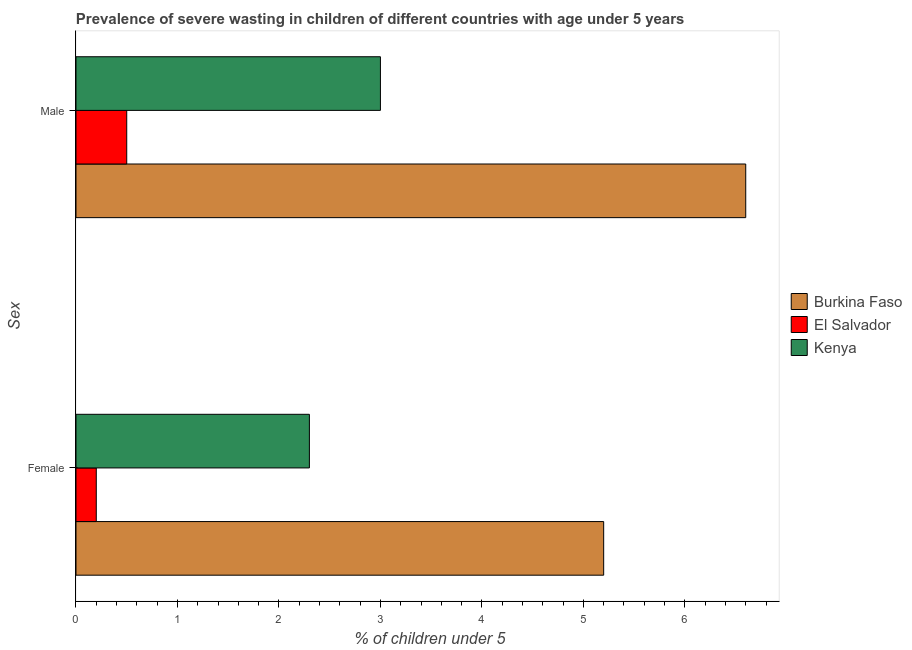How many groups of bars are there?
Provide a succinct answer. 2. Are the number of bars per tick equal to the number of legend labels?
Ensure brevity in your answer.  Yes. How many bars are there on the 1st tick from the bottom?
Provide a succinct answer. 3. What is the percentage of undernourished female children in Kenya?
Provide a succinct answer. 2.3. Across all countries, what is the maximum percentage of undernourished male children?
Ensure brevity in your answer.  6.6. Across all countries, what is the minimum percentage of undernourished female children?
Make the answer very short. 0.2. In which country was the percentage of undernourished female children maximum?
Keep it short and to the point. Burkina Faso. In which country was the percentage of undernourished female children minimum?
Your answer should be very brief. El Salvador. What is the total percentage of undernourished male children in the graph?
Your response must be concise. 10.1. What is the difference between the percentage of undernourished male children in Kenya and that in Burkina Faso?
Provide a short and direct response. -3.6. What is the difference between the percentage of undernourished male children in Burkina Faso and the percentage of undernourished female children in El Salvador?
Keep it short and to the point. 6.4. What is the average percentage of undernourished female children per country?
Offer a terse response. 2.57. What is the difference between the percentage of undernourished female children and percentage of undernourished male children in El Salvador?
Make the answer very short. -0.3. In how many countries, is the percentage of undernourished female children greater than 5.6 %?
Offer a terse response. 0. What is the ratio of the percentage of undernourished male children in Kenya to that in Burkina Faso?
Ensure brevity in your answer.  0.45. Is the percentage of undernourished male children in Kenya less than that in El Salvador?
Your answer should be very brief. No. In how many countries, is the percentage of undernourished female children greater than the average percentage of undernourished female children taken over all countries?
Your response must be concise. 1. What does the 1st bar from the top in Male represents?
Your answer should be very brief. Kenya. What does the 3rd bar from the bottom in Male represents?
Provide a short and direct response. Kenya. How many bars are there?
Provide a short and direct response. 6. How many countries are there in the graph?
Make the answer very short. 3. What is the difference between two consecutive major ticks on the X-axis?
Offer a terse response. 1. Are the values on the major ticks of X-axis written in scientific E-notation?
Make the answer very short. No. Does the graph contain any zero values?
Keep it short and to the point. No. Where does the legend appear in the graph?
Ensure brevity in your answer.  Center right. How are the legend labels stacked?
Make the answer very short. Vertical. What is the title of the graph?
Provide a short and direct response. Prevalence of severe wasting in children of different countries with age under 5 years. Does "Middle East & North Africa (all income levels)" appear as one of the legend labels in the graph?
Provide a succinct answer. No. What is the label or title of the X-axis?
Give a very brief answer.  % of children under 5. What is the label or title of the Y-axis?
Provide a short and direct response. Sex. What is the  % of children under 5 in Burkina Faso in Female?
Your response must be concise. 5.2. What is the  % of children under 5 of El Salvador in Female?
Your answer should be compact. 0.2. What is the  % of children under 5 of Kenya in Female?
Offer a terse response. 2.3. What is the  % of children under 5 of Burkina Faso in Male?
Keep it short and to the point. 6.6. What is the  % of children under 5 in El Salvador in Male?
Keep it short and to the point. 0.5. Across all Sex, what is the maximum  % of children under 5 of Burkina Faso?
Provide a short and direct response. 6.6. Across all Sex, what is the maximum  % of children under 5 of El Salvador?
Your answer should be very brief. 0.5. Across all Sex, what is the maximum  % of children under 5 of Kenya?
Keep it short and to the point. 3. Across all Sex, what is the minimum  % of children under 5 in Burkina Faso?
Make the answer very short. 5.2. Across all Sex, what is the minimum  % of children under 5 of El Salvador?
Offer a very short reply. 0.2. Across all Sex, what is the minimum  % of children under 5 in Kenya?
Offer a very short reply. 2.3. What is the total  % of children under 5 in El Salvador in the graph?
Provide a succinct answer. 0.7. What is the total  % of children under 5 in Kenya in the graph?
Give a very brief answer. 5.3. What is the difference between the  % of children under 5 in Burkina Faso in Female and that in Male?
Keep it short and to the point. -1.4. What is the difference between the  % of children under 5 in El Salvador in Female and that in Male?
Your answer should be compact. -0.3. What is the difference between the  % of children under 5 in Kenya in Female and that in Male?
Provide a short and direct response. -0.7. What is the average  % of children under 5 of Burkina Faso per Sex?
Ensure brevity in your answer.  5.9. What is the average  % of children under 5 of El Salvador per Sex?
Your answer should be compact. 0.35. What is the average  % of children under 5 of Kenya per Sex?
Ensure brevity in your answer.  2.65. What is the difference between the  % of children under 5 of Burkina Faso and  % of children under 5 of Kenya in Female?
Give a very brief answer. 2.9. What is the difference between the  % of children under 5 in El Salvador and  % of children under 5 in Kenya in Male?
Your answer should be compact. -2.5. What is the ratio of the  % of children under 5 of Burkina Faso in Female to that in Male?
Your answer should be very brief. 0.79. What is the ratio of the  % of children under 5 in Kenya in Female to that in Male?
Provide a succinct answer. 0.77. What is the difference between the highest and the second highest  % of children under 5 in Kenya?
Keep it short and to the point. 0.7. What is the difference between the highest and the lowest  % of children under 5 of Burkina Faso?
Your answer should be compact. 1.4. What is the difference between the highest and the lowest  % of children under 5 in El Salvador?
Offer a very short reply. 0.3. What is the difference between the highest and the lowest  % of children under 5 in Kenya?
Your response must be concise. 0.7. 